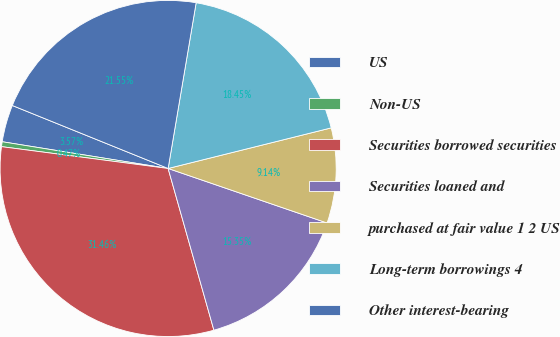Convert chart. <chart><loc_0><loc_0><loc_500><loc_500><pie_chart><fcel>US<fcel>Non-US<fcel>Securities borrowed securities<fcel>Securities loaned and<fcel>purchased at fair value 1 2 US<fcel>Long-term borrowings 4<fcel>Other interest-bearing<nl><fcel>3.57%<fcel>0.47%<fcel>31.46%<fcel>15.35%<fcel>9.14%<fcel>18.45%<fcel>21.55%<nl></chart> 